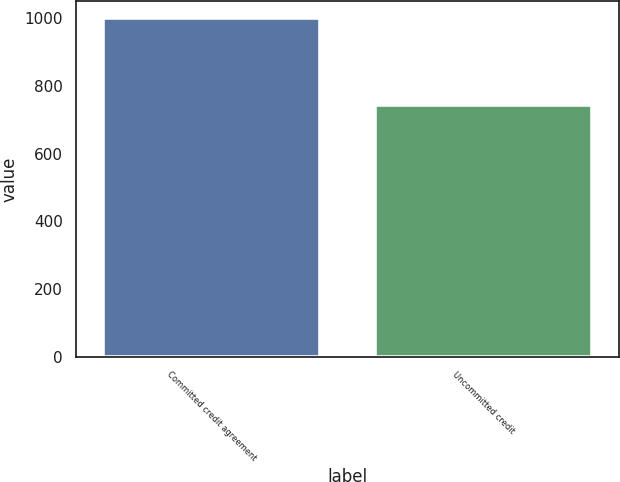Convert chart to OTSL. <chart><loc_0><loc_0><loc_500><loc_500><bar_chart><fcel>Committed credit agreement<fcel>Uncommitted credit<nl><fcel>1000<fcel>744.5<nl></chart> 